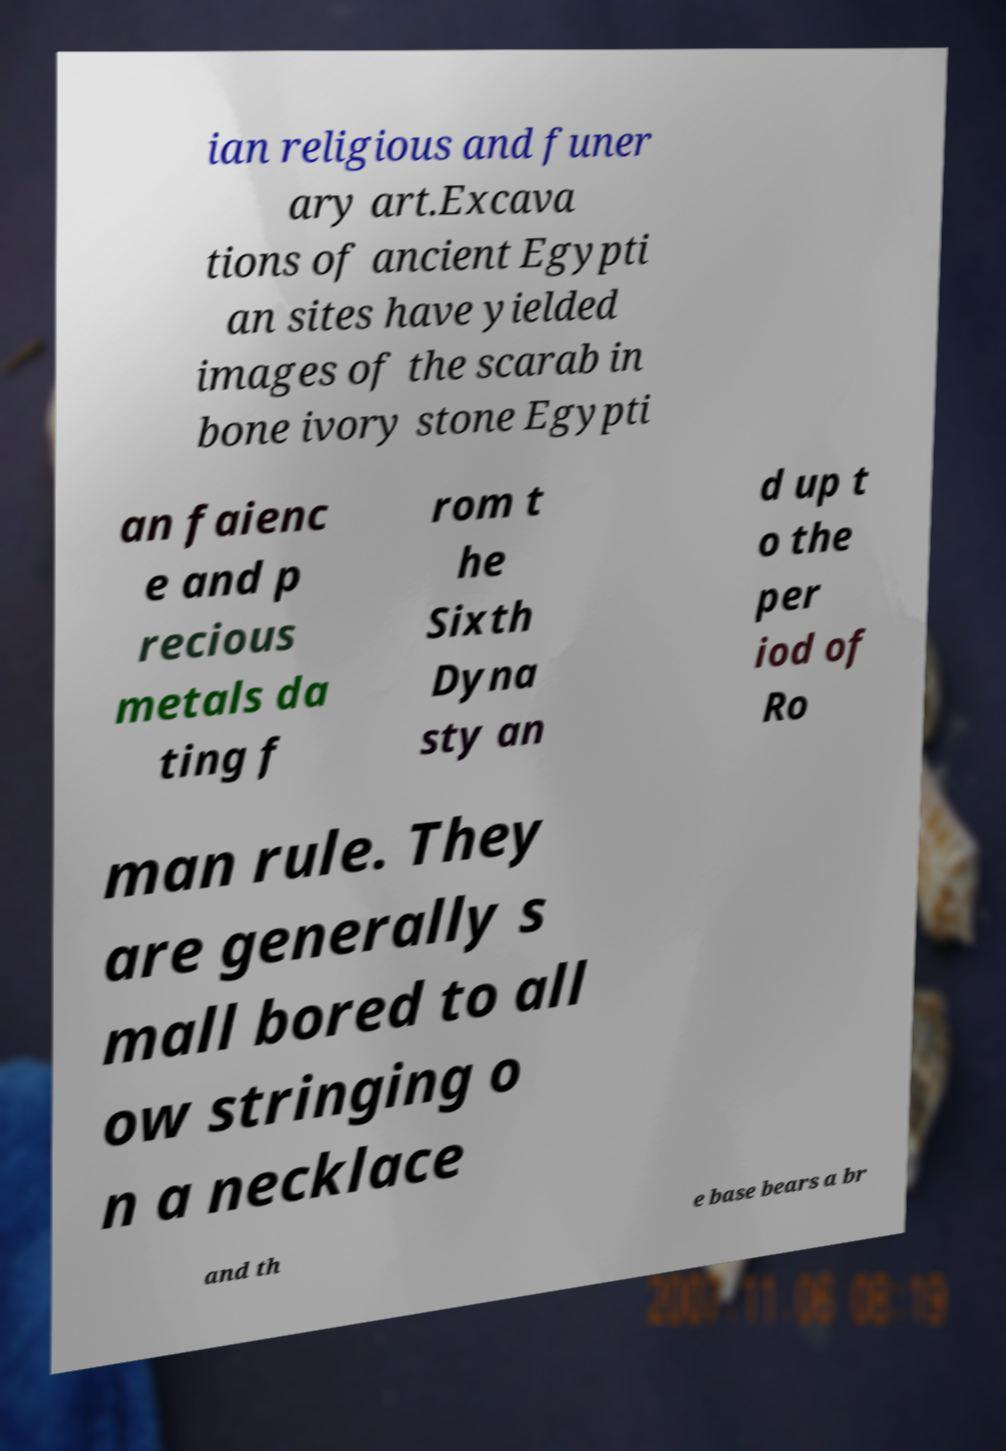Could you assist in decoding the text presented in this image and type it out clearly? ian religious and funer ary art.Excava tions of ancient Egypti an sites have yielded images of the scarab in bone ivory stone Egypti an faienc e and p recious metals da ting f rom t he Sixth Dyna sty an d up t o the per iod of Ro man rule. They are generally s mall bored to all ow stringing o n a necklace and th e base bears a br 